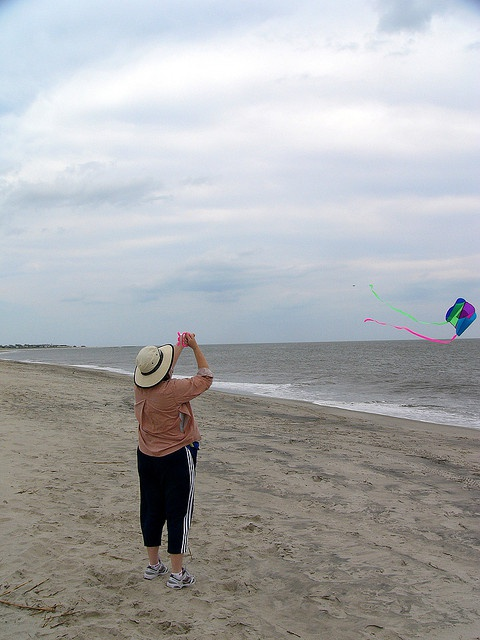Describe the objects in this image and their specific colors. I can see people in darkgray, black, gray, and brown tones and kite in darkgray, blue, teal, darkblue, and darkgreen tones in this image. 